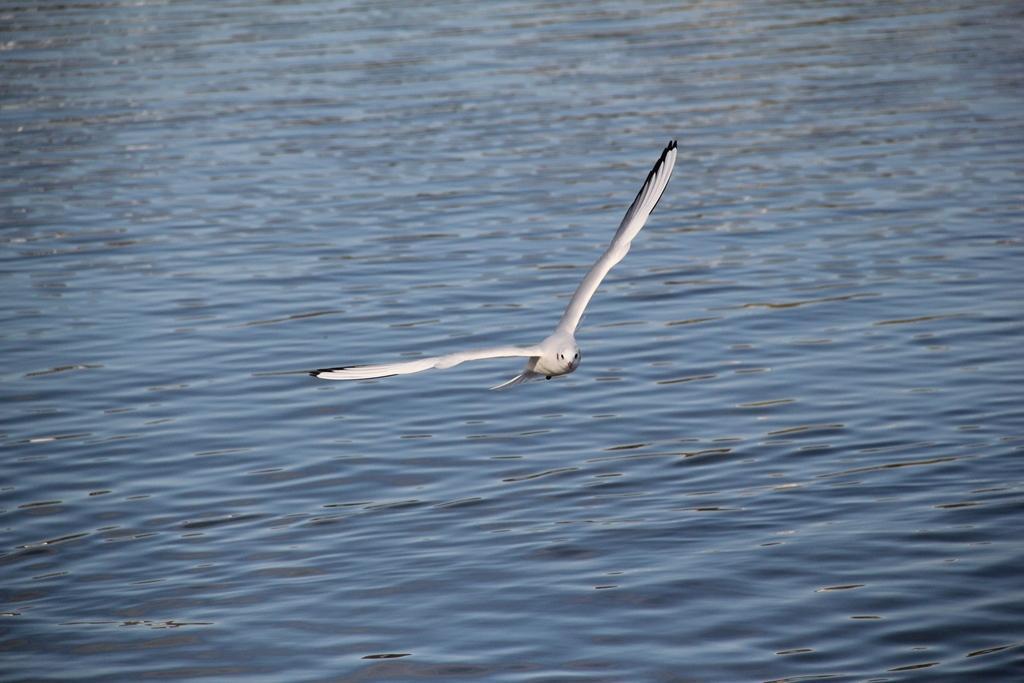Describe this image in one or two sentences. In this image we can see a bird. In the background of the image there is water. 